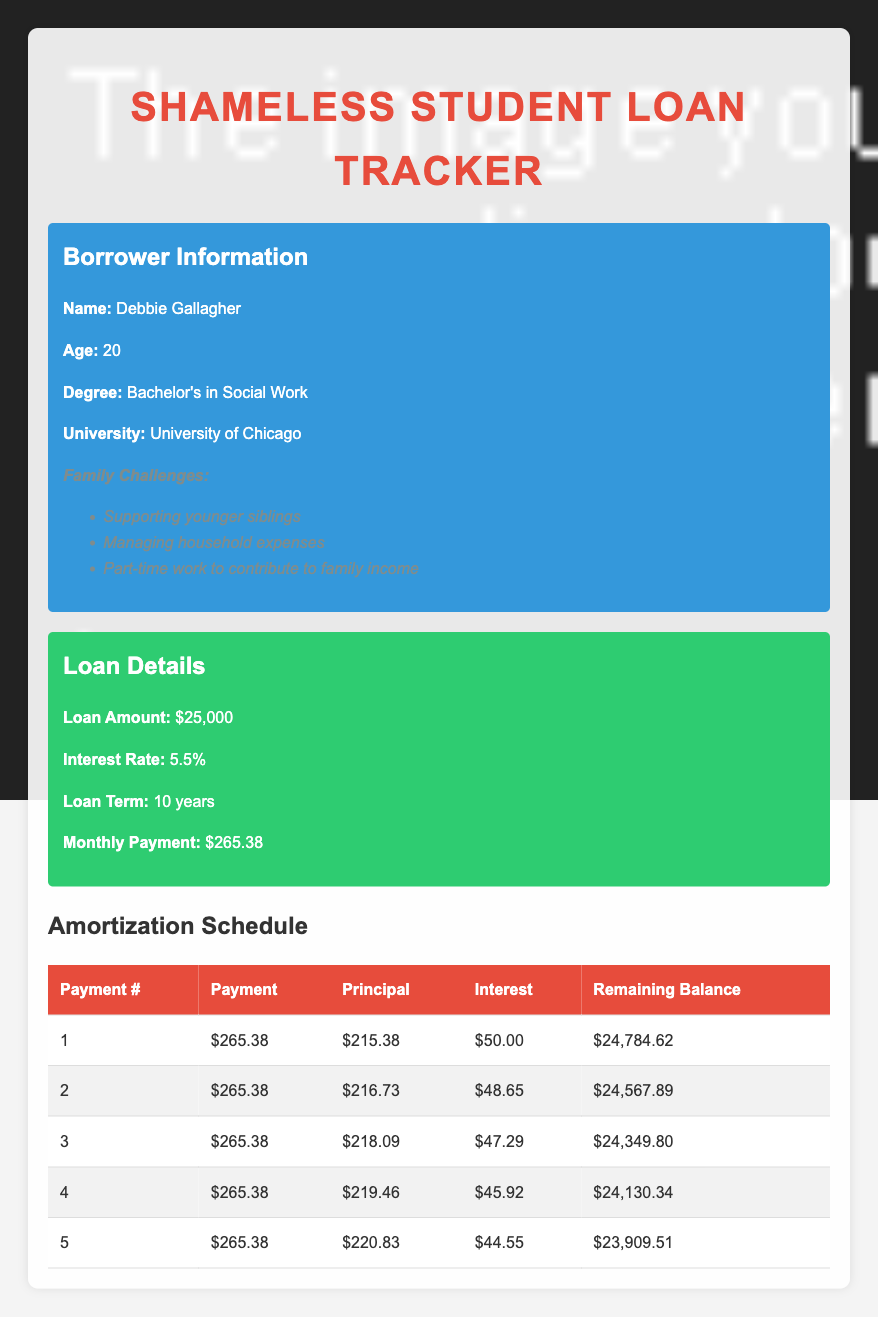What is the monthly payment for Debbie Gallagher's student loan? The table shows a specific row for loan details which states that the monthly payment is $265.38.
Answer: 265.38 How much principal is paid in the second payment? In the table, under the second payment entry, the principal amount is listed as $216.73.
Answer: 216.73 What is the total interest paid in the first five payments? To find the total interest paid, sum the interest amounts for the first five payments: (50.00 + 48.65 + 47.29 + 45.92 + 44.55) = 236.41.
Answer: 236.41 Is the remaining balance after the third payment higher than $24,000? The remaining balance after the third payment is $24,349.80, which is higher than $24,000. Thus, the statement is true.
Answer: Yes What is the average principal paid per payment for the first five payments? To find the average principal out of the five payments, sum the principal amounts: (215.38 + 216.73 + 218.09 + 219.46 + 220.83) = 1090.49. Then divide by 5 to find the average: 1090.49 / 5 = 218.10.
Answer: 218.10 How much less is the interest paid in the fifth payment compared to the first payment? The interest for the first payment is $50.00 and for the fifth payment it is $44.55. The difference is calculated as $50.00 - $44.55 = $5.45, indicating that the interest paid in the fifth payment is $5.45 less than the first payment.
Answer: 5.45 What is the remaining balance after the first payment? In the first payment, the remaining balance is stated as $24,784.62 in the table.
Answer: 24,784.62 Does the monthly payment cover more of the principal than interest in the fourth payment? In the fourth payment, the principal is $219.46 and the interest is $45.92. Since $219.46 is greater than $45.92, the monthly payment does indeed cover more of the principal than the interest.
Answer: Yes What is the total loan amount Debbie has taken? The loan details indicate that the total loan amount taken by Debbie is $25,000.
Answer: 25,000 